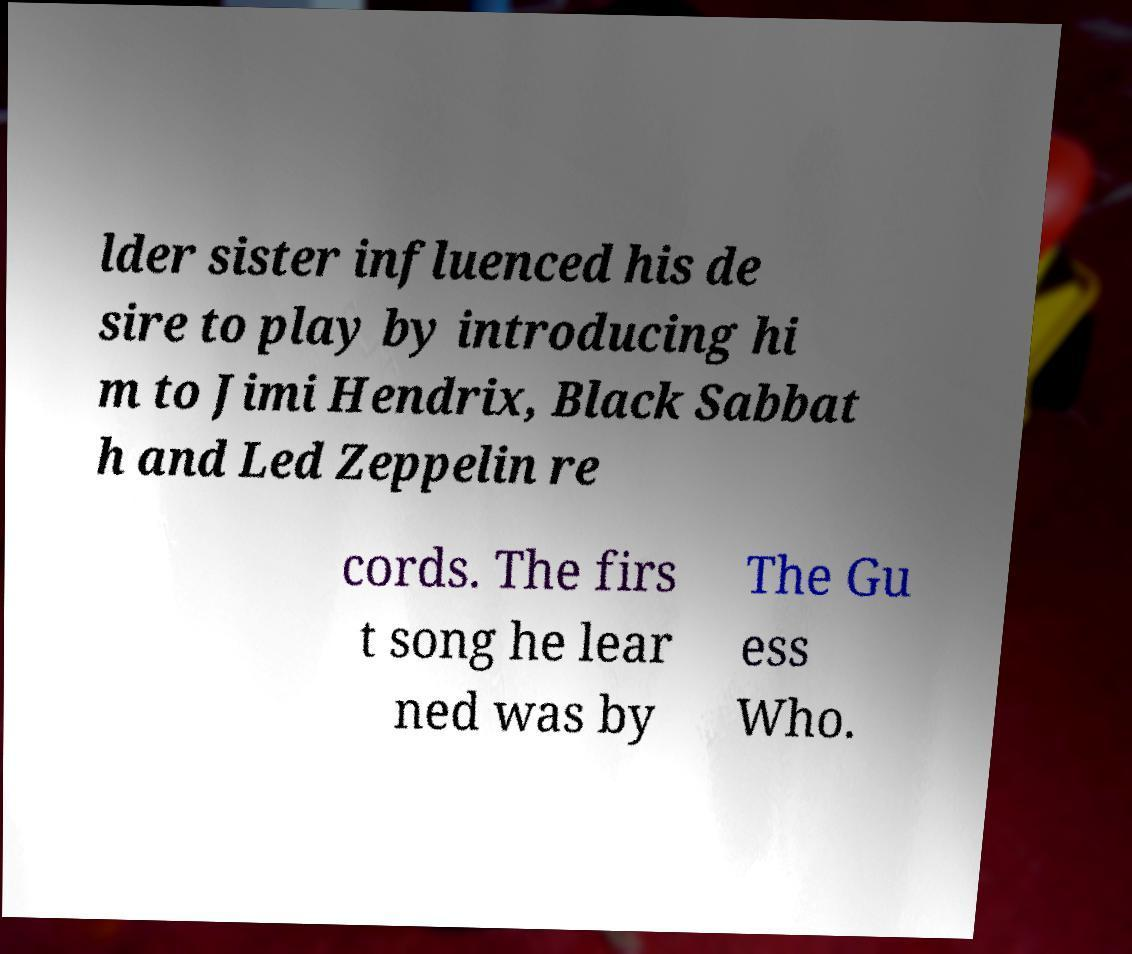Could you extract and type out the text from this image? lder sister influenced his de sire to play by introducing hi m to Jimi Hendrix, Black Sabbat h and Led Zeppelin re cords. The firs t song he lear ned was by The Gu ess Who. 